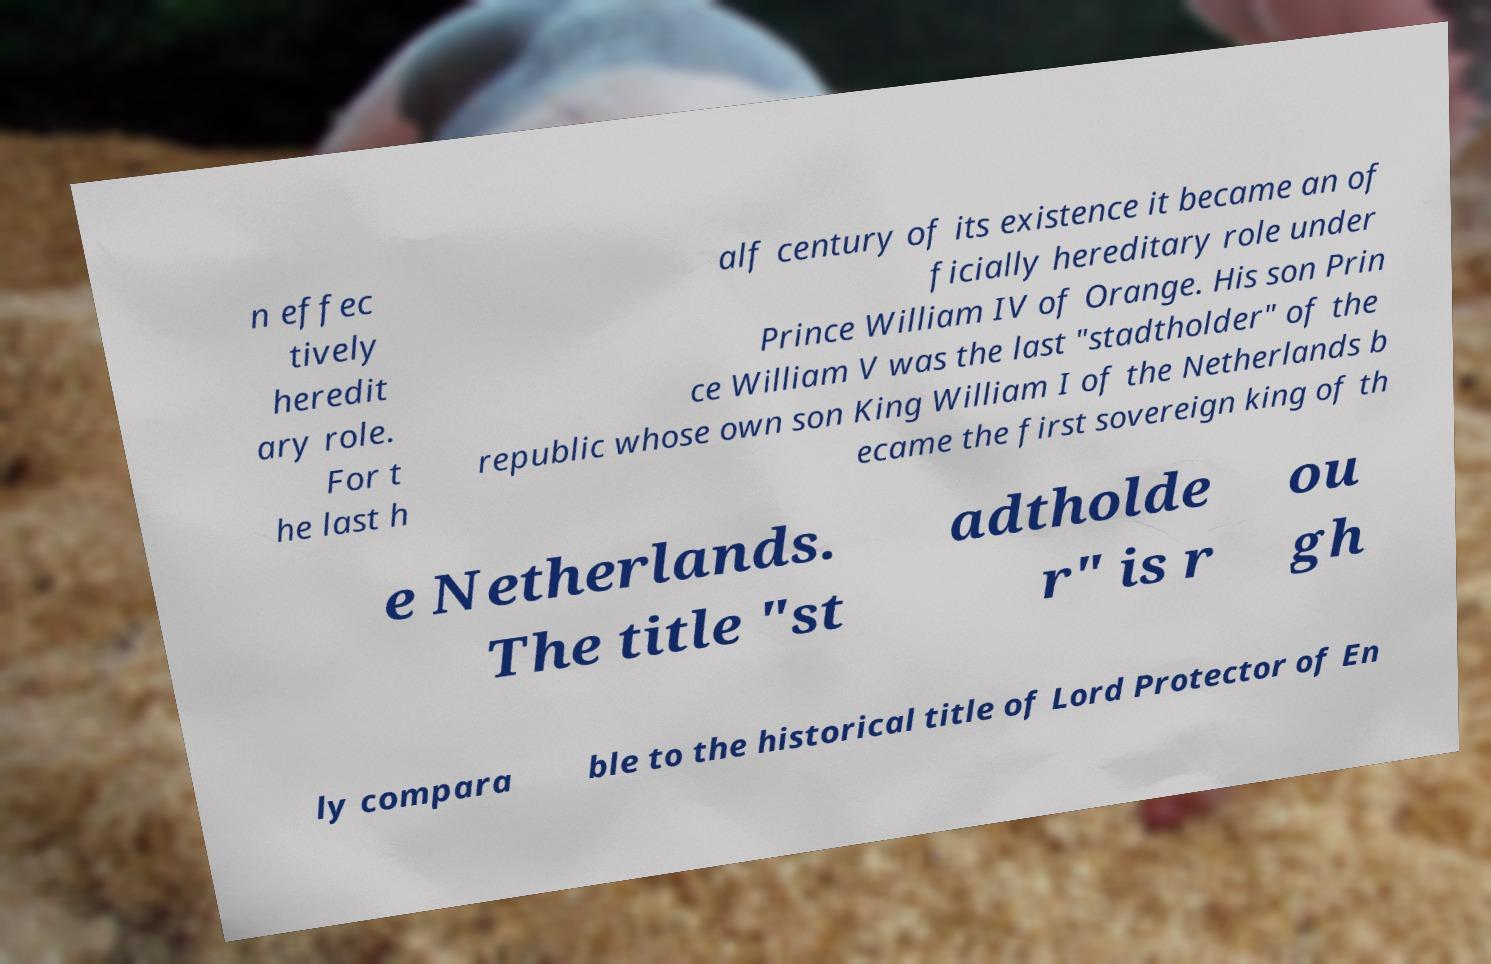Could you extract and type out the text from this image? n effec tively heredit ary role. For t he last h alf century of its existence it became an of ficially hereditary role under Prince William IV of Orange. His son Prin ce William V was the last "stadtholder" of the republic whose own son King William I of the Netherlands b ecame the first sovereign king of th e Netherlands. The title "st adtholde r" is r ou gh ly compara ble to the historical title of Lord Protector of En 